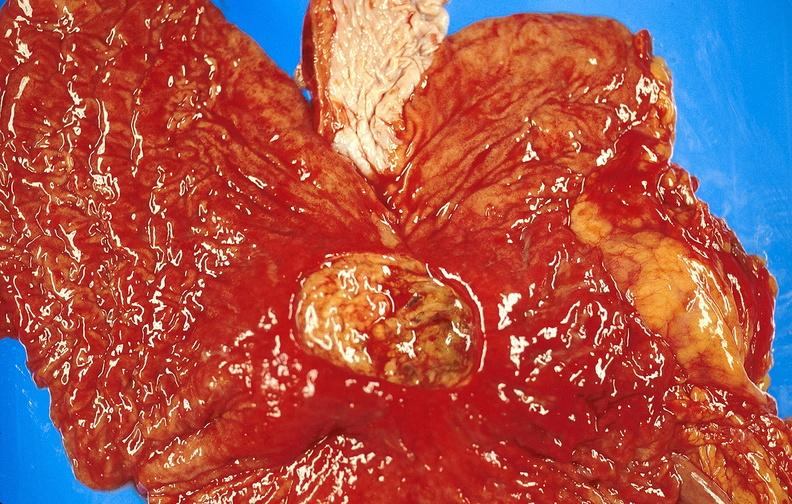s retroperitoneal liposarcoma present?
Answer the question using a single word or phrase. No 